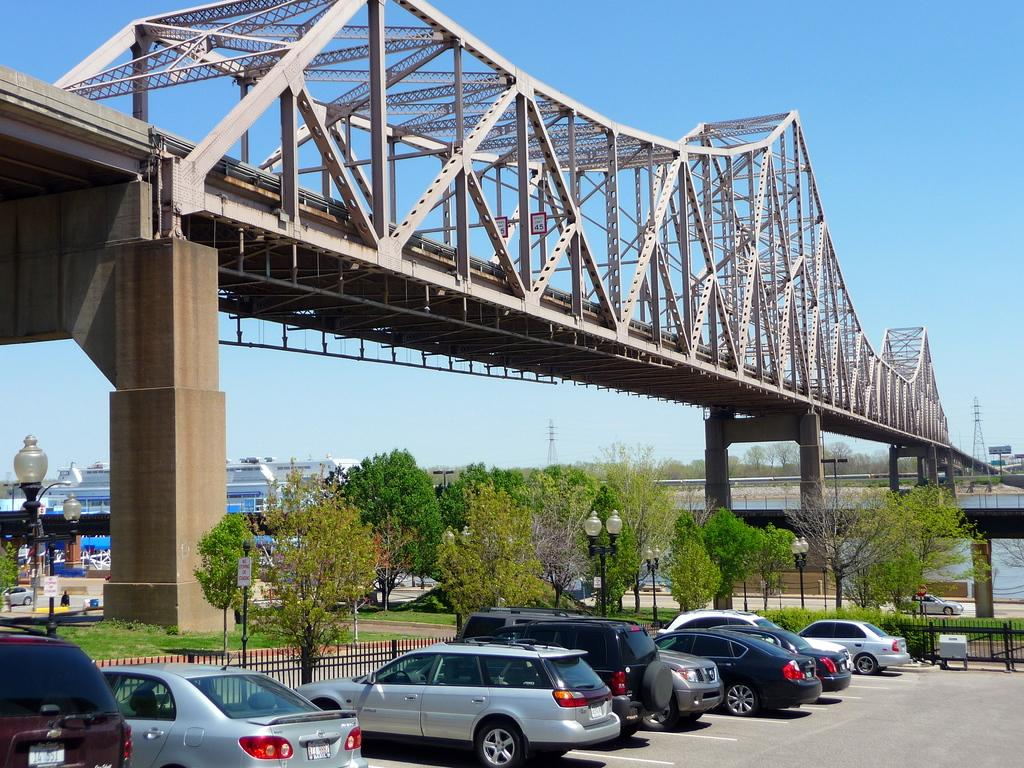What can be seen in the image that is used for transportation? There are vehicles parked in the image. What is above the parked vehicles in the image? There is a bridge above the parked vehicles. What type of natural elements can be seen in the background of the image? There are trees in the background of the image. What type of man-made structures can be seen in the background of the image? There are buildings in the background of the image. What brand of toothpaste is advertised on the bridge in the image? There is no toothpaste or advertisement present on the bridge in the image. What type of crack can be seen on the vehicles in the image? There is no mention of any cracks on the vehicles in the image. 